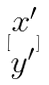<formula> <loc_0><loc_0><loc_500><loc_500>[ \begin{matrix} x ^ { \prime } \\ y ^ { \prime } \end{matrix} ]</formula> 